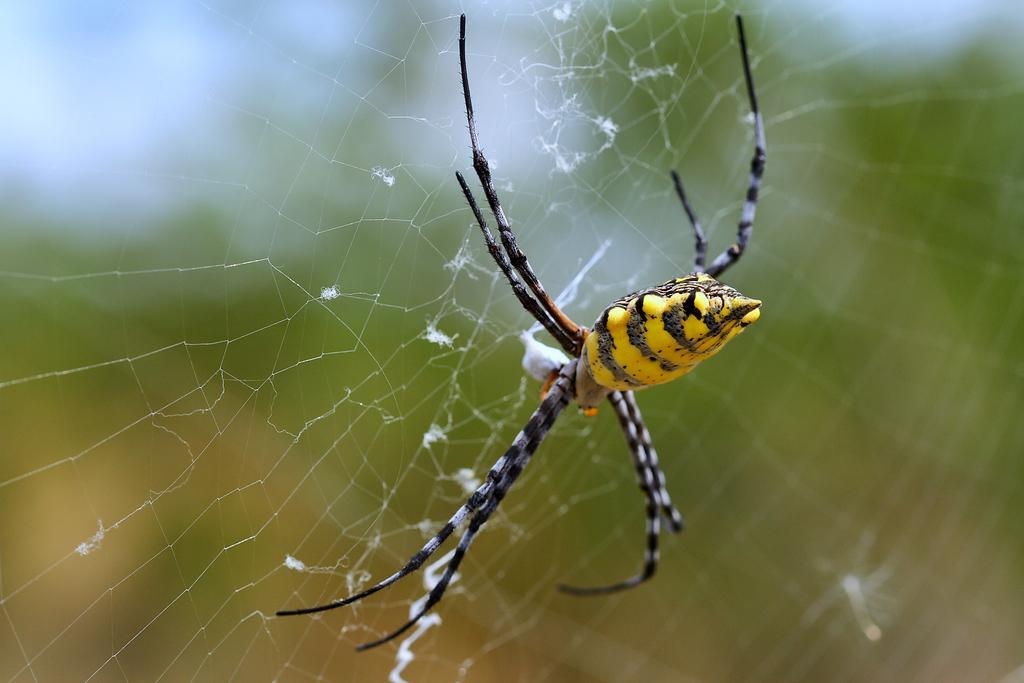Could you give a brief overview of what you see in this image? There is a spider on a web in the foreground area of the image and the background is blurry. 